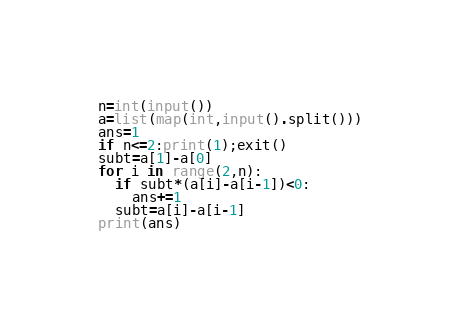Convert code to text. <code><loc_0><loc_0><loc_500><loc_500><_Python_>n=int(input())
a=list(map(int,input().split()))
ans=1
if n<=2:print(1);exit()
subt=a[1]-a[0]
for i in range(2,n):
  if subt*(a[i]-a[i-1])<0:
    ans+=1
  subt=a[i]-a[i-1]
print(ans)</code> 